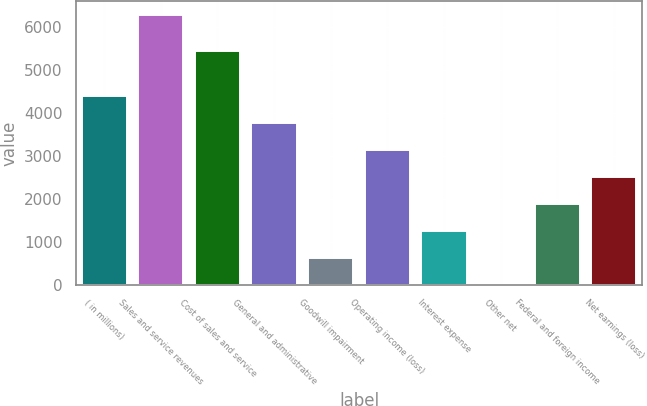Convert chart. <chart><loc_0><loc_0><loc_500><loc_500><bar_chart><fcel>( in millions)<fcel>Sales and service revenues<fcel>Cost of sales and service<fcel>General and administrative<fcel>Goodwill impairment<fcel>Operating income (loss)<fcel>Interest expense<fcel>Other net<fcel>Federal and foreign income<fcel>Net earnings (loss)<nl><fcel>4404.7<fcel>6292<fcel>5442<fcel>3775.6<fcel>630.1<fcel>3146.5<fcel>1259.2<fcel>1<fcel>1888.3<fcel>2517.4<nl></chart> 